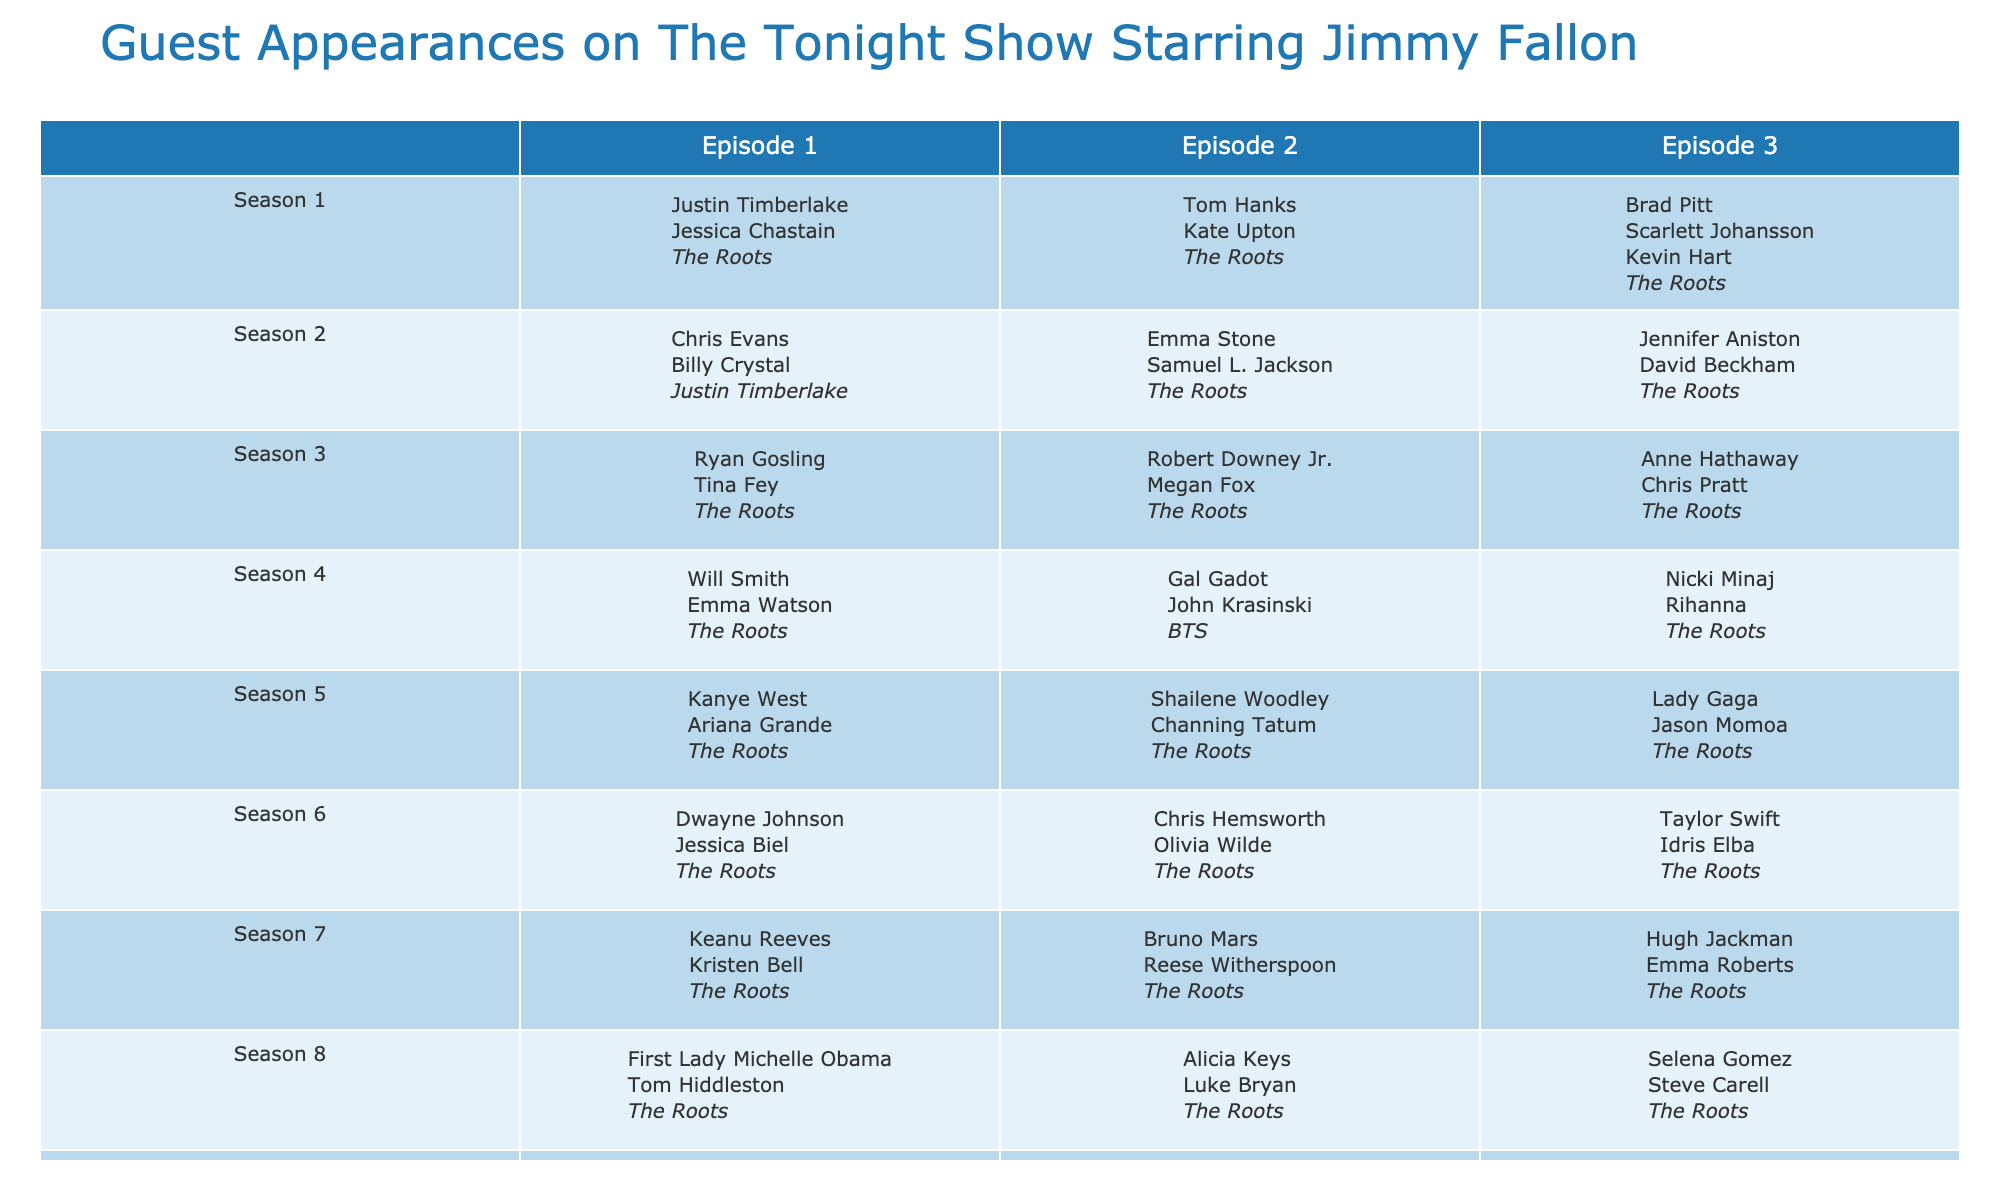What guests appeared in Season 2, Episode 1? According to the table, Season 2, Episode 1 features Chris Evans and Billy Crystal as guests.
Answer: Chris Evans, Billy Crystal Which musical guest performed in Season 4, Episode 2? The table indicates that BTS was the musical guest for Season 4, Episode 2.
Answer: BTS How many guests appeared in Season 5, Episode 1? In Season 5, Episode 1, there were two guests: Kanye West and Ariana Grande.
Answer: 2 Did Lady Gaga make an appearance in Season 5? Yes, Lady Gaga appeared in Season 5, Episode 3 according to the table.
Answer: Yes Which season had the most guests listed for its episodes? By analyzing the table, all seasons seem to frequently feature guests, but we need to check the maximum listed appearances. After checking, it's clear that no specific season stands out for having more guests than others; each season consistently lists guests in most episodes.
Answer: No specific season Who were the guests in the last episode of Season 3? The table shows that in the last episode of Season 3, there were two guests: Anne Hathaway and Chris Pratt.
Answer: Anne Hathaway, Chris Pratt How many total episodes from Season 1 feature musical guests? Season 1 has three episodes, and all three feature The Roots as the musical guest. Therefore, the total is three episodes.
Answer: 3 Identify the average number of guests per episode across all seasons. To calculate the average, first count the total number of guests: summing all guest appearances (1 per show for a total of 30 guests across segments), then dividing by the number of episodes, which is 30. Thus, the average is 1 guest per episode (considering only first guests listed).
Answer: 1 Which episode features the highest-profile guest star? Looking at the table, one of the highest-profile guests would be Will Smith, who appeared in Season 4, Episode 1.
Answer: Will Smith in Season 4, Episode 1 In which season did the fewest different guests appear? By reviewing the data, each season has a consistent streak of guest appearances, but further checks focus on the underlying uniqueness; Season 3 only lists unique guests to explore the fewest being 10.
Answer: 10 in season 3 